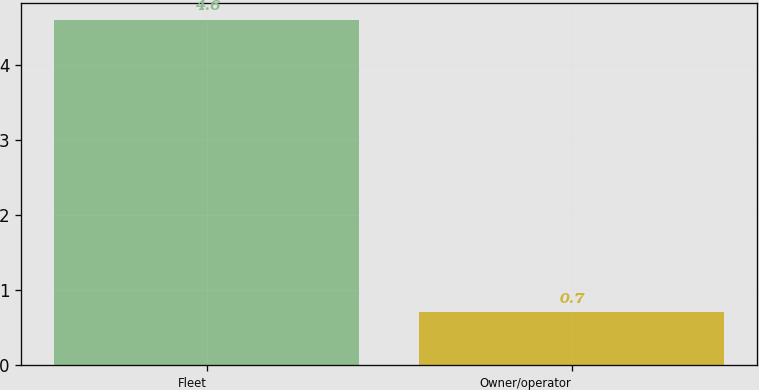Convert chart. <chart><loc_0><loc_0><loc_500><loc_500><bar_chart><fcel>Fleet<fcel>Owner/operator<nl><fcel>4.6<fcel>0.7<nl></chart> 